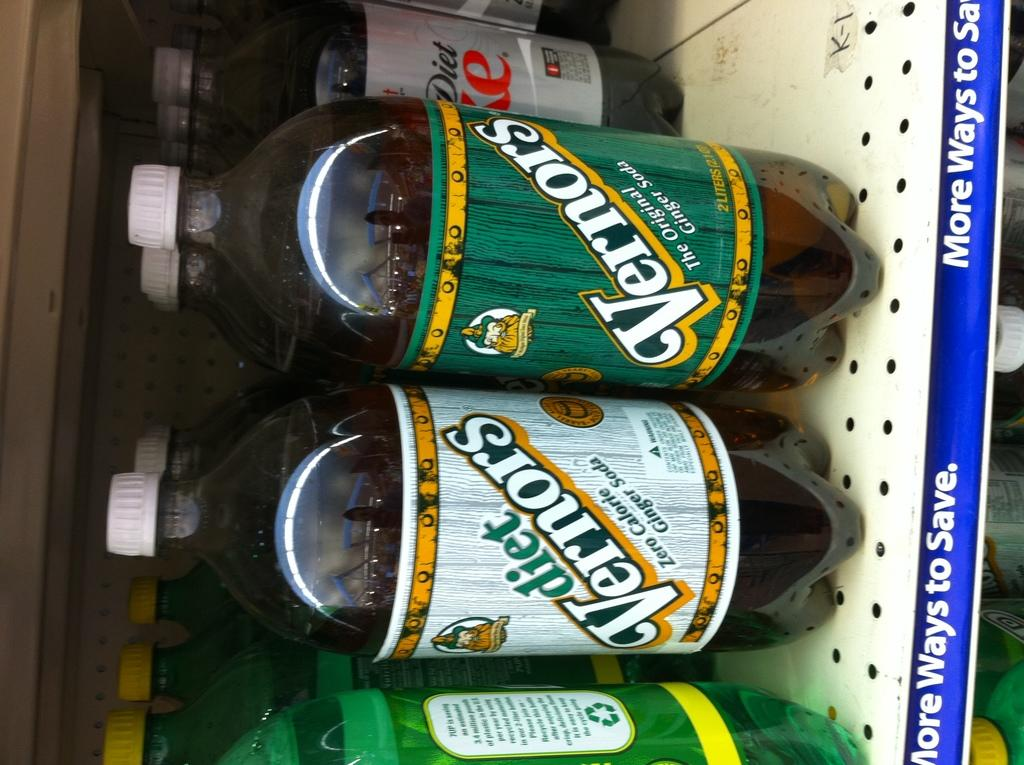<image>
Offer a succinct explanation of the picture presented. Bottles of  diet Vernors and cokes setting on a shelf. 